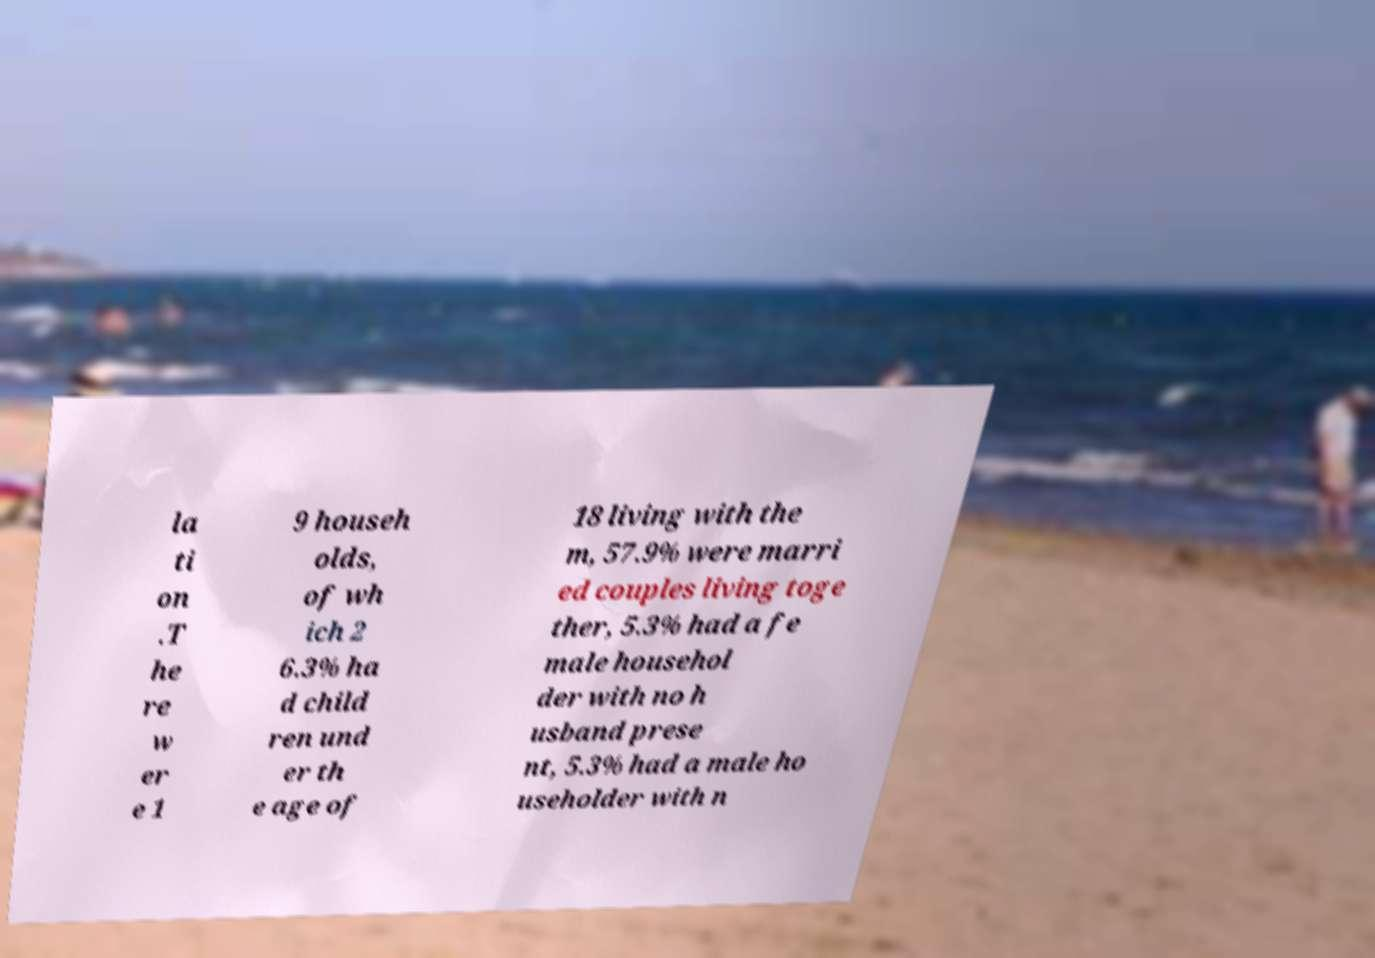For documentation purposes, I need the text within this image transcribed. Could you provide that? la ti on .T he re w er e 1 9 househ olds, of wh ich 2 6.3% ha d child ren und er th e age of 18 living with the m, 57.9% were marri ed couples living toge ther, 5.3% had a fe male househol der with no h usband prese nt, 5.3% had a male ho useholder with n 